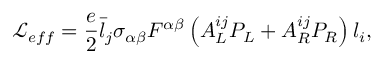Convert formula to latex. <formula><loc_0><loc_0><loc_500><loc_500>\mathcal { L } _ { e f f } = \frac { e } { 2 } \bar { l } _ { j } \sigma _ { \alpha \beta } F ^ { \alpha \beta } \left ( A _ { L } ^ { i j } P _ { L } + A _ { R } ^ { i j } P _ { R } \right ) l _ { i } ,</formula> 